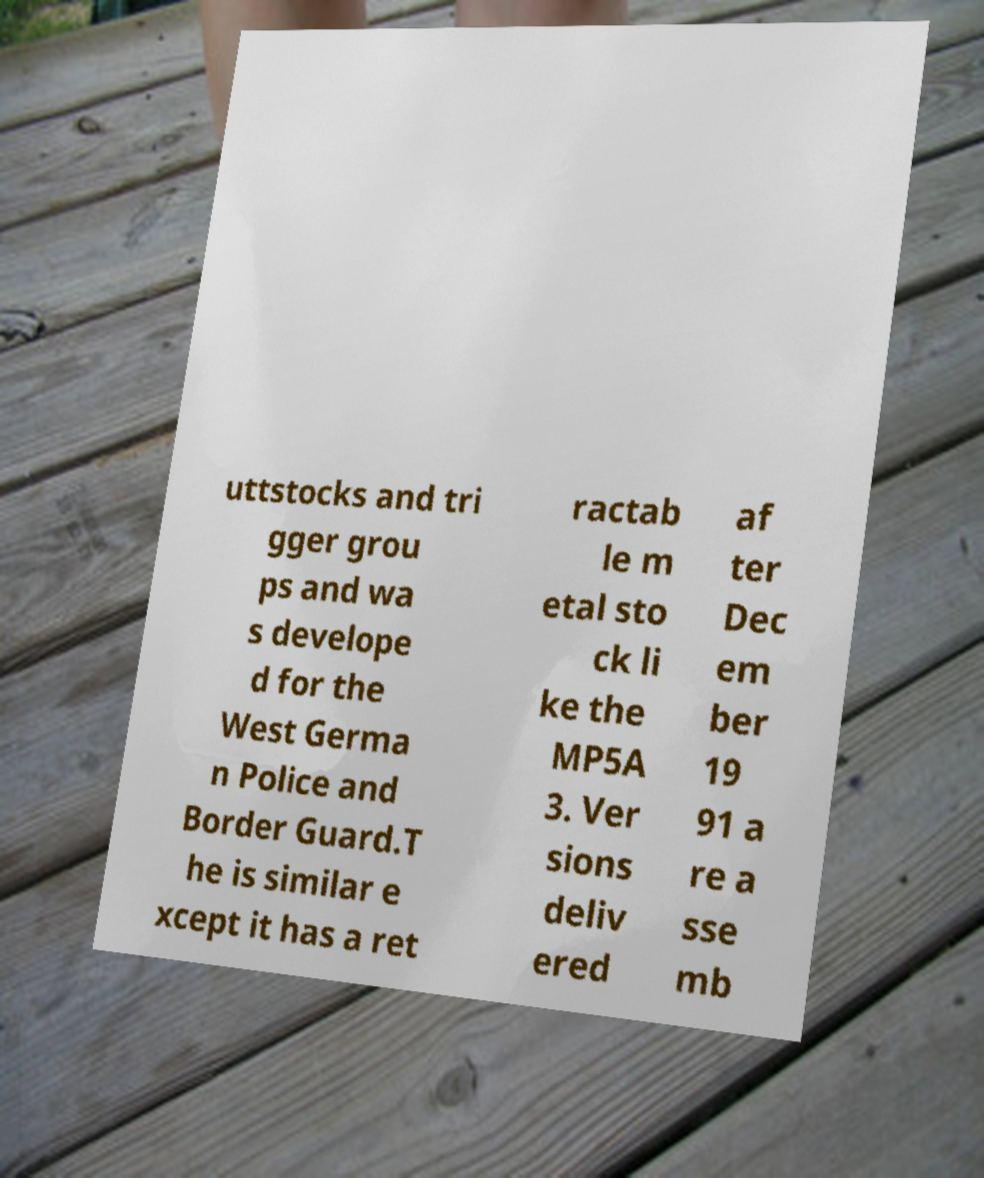Please read and relay the text visible in this image. What does it say? uttstocks and tri gger grou ps and wa s develope d for the West Germa n Police and Border Guard.T he is similar e xcept it has a ret ractab le m etal sto ck li ke the MP5A 3. Ver sions deliv ered af ter Dec em ber 19 91 a re a sse mb 